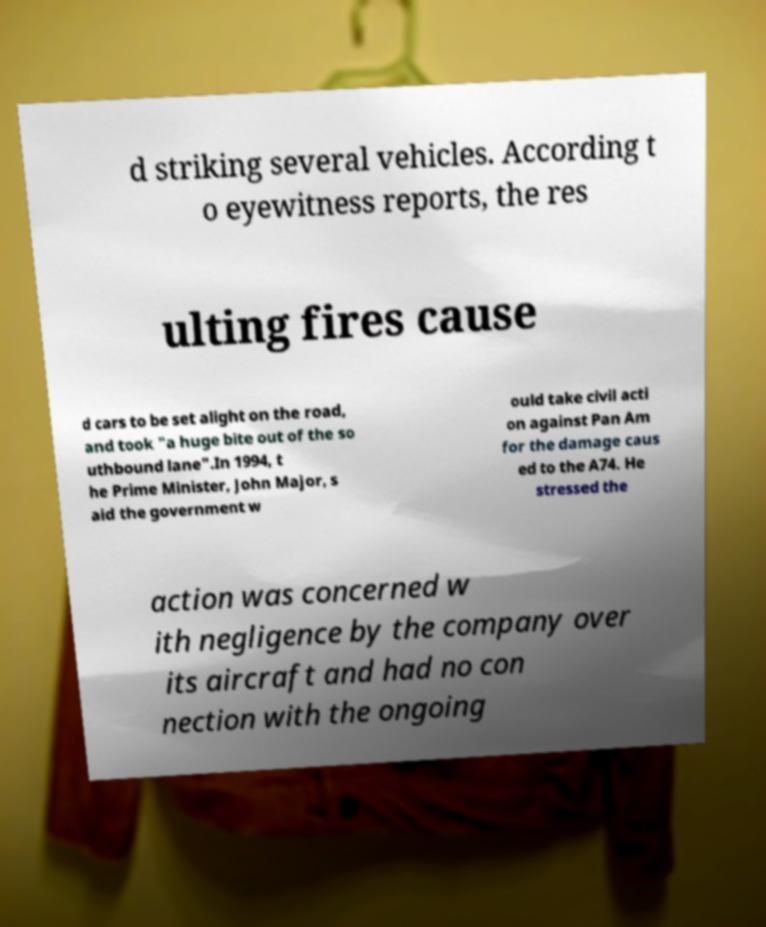Can you accurately transcribe the text from the provided image for me? d striking several vehicles. According t o eyewitness reports, the res ulting fires cause d cars to be set alight on the road, and took "a huge bite out of the so uthbound lane".In 1994, t he Prime Minister, John Major, s aid the government w ould take civil acti on against Pan Am for the damage caus ed to the A74. He stressed the action was concerned w ith negligence by the company over its aircraft and had no con nection with the ongoing 